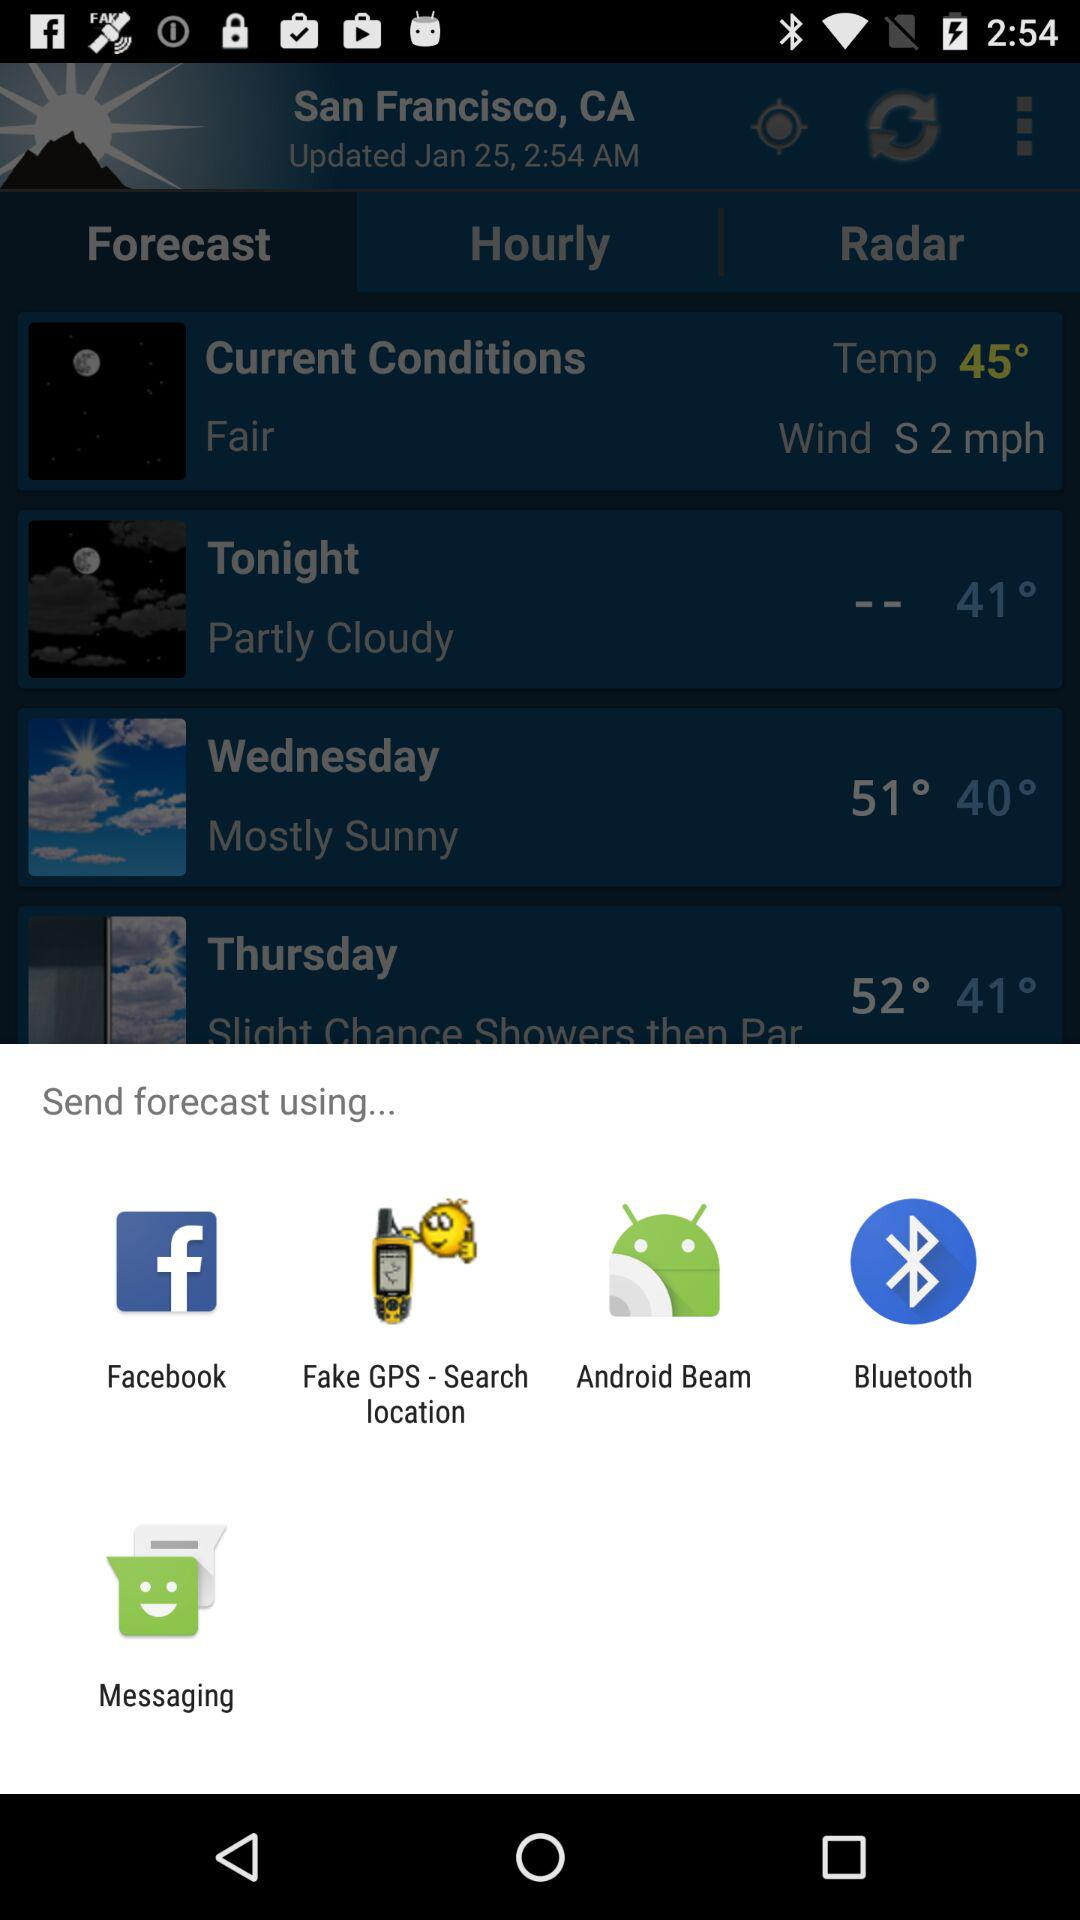What is the current temperature? The current temperature is 45°. 